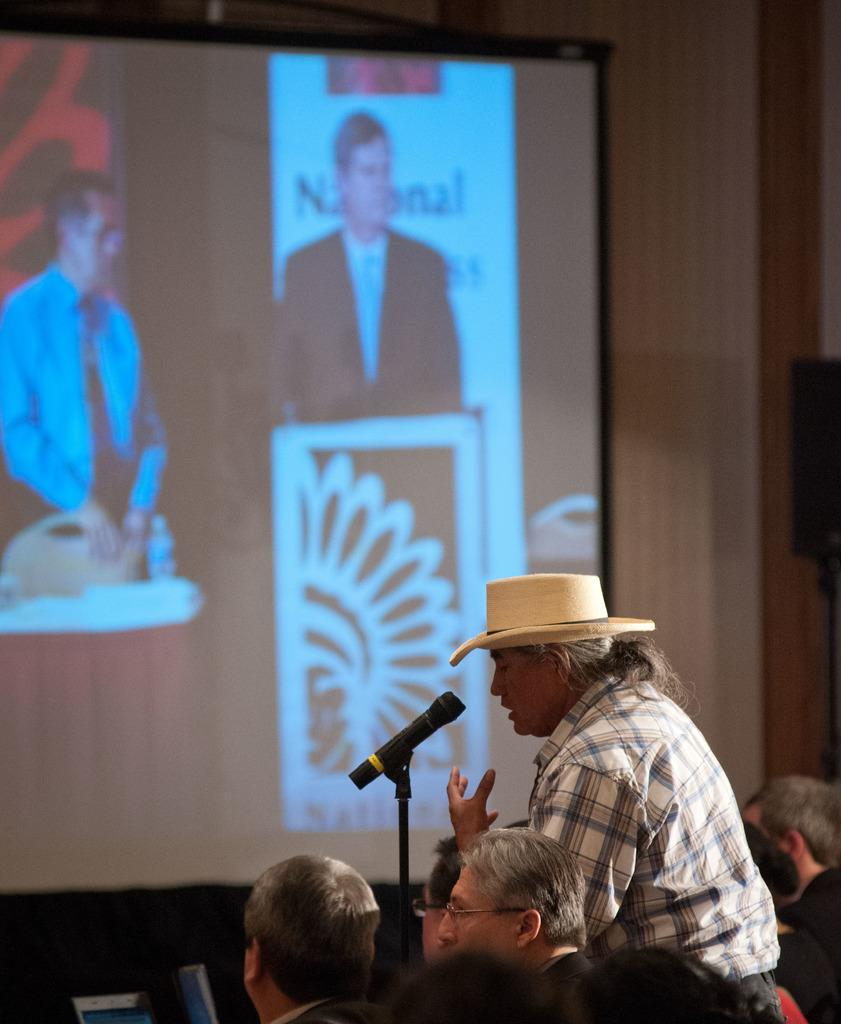What is happening at the bottom of the image? There are persons at the bottom of the image. What is the person in the middle of the image doing? A person is speaking in a microphone in the middle of the image. Can you describe the appearance of the person speaking? The person speaking is wearing a hat. What can be seen in the background of the image? There is a projector screen in the background of the image. What type of juice is being served to the audience in the image? There is no juice being served in the image; the focus is on the person speaking in a microphone. How does the father in the image interact with the projector screen? There is no father present in the image, and therefore no interaction with the projector screen can be observed. 